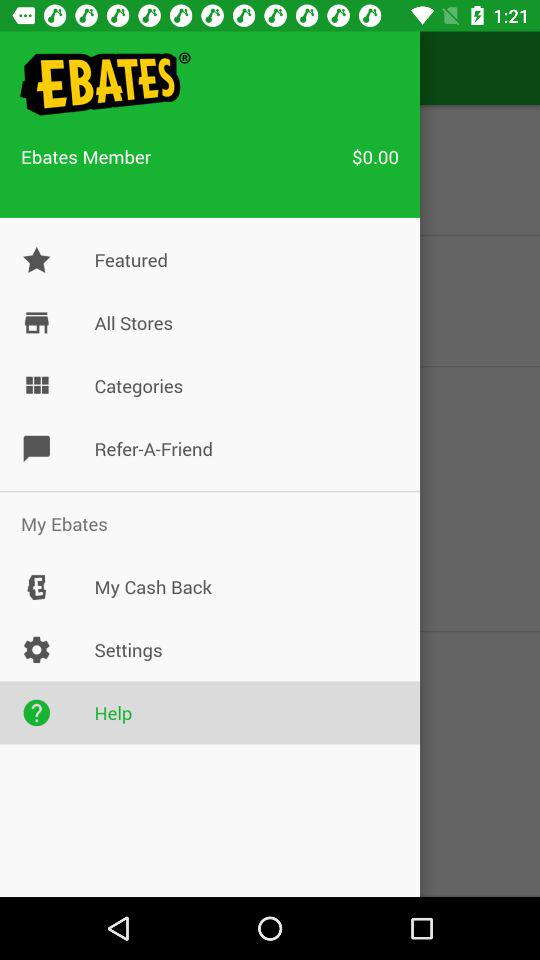What is the amount for Ebates members? The amount for Ebates members is $0.00. 